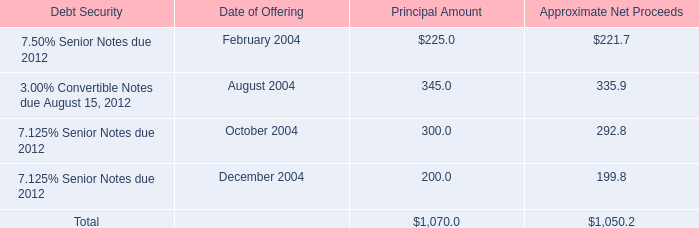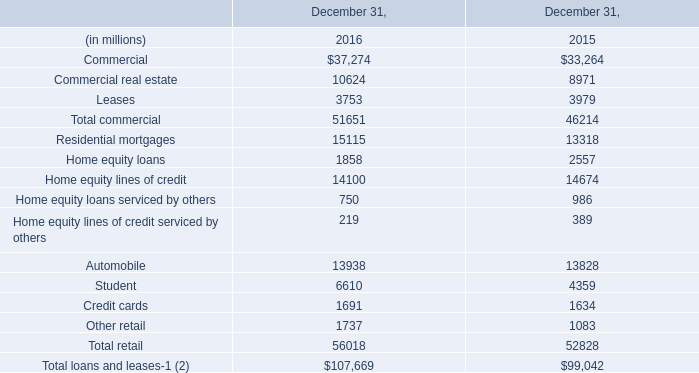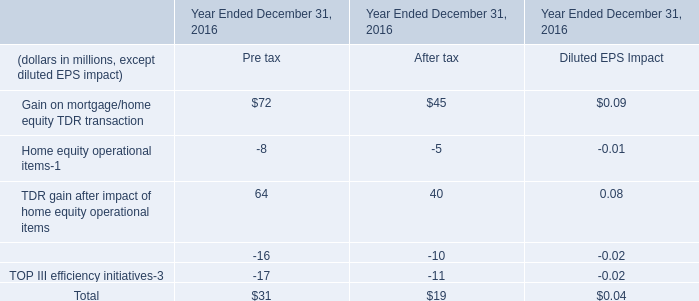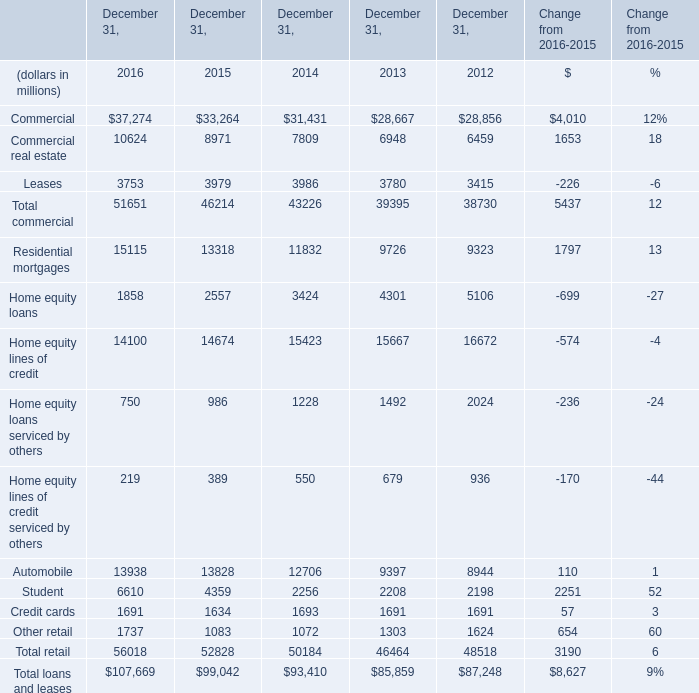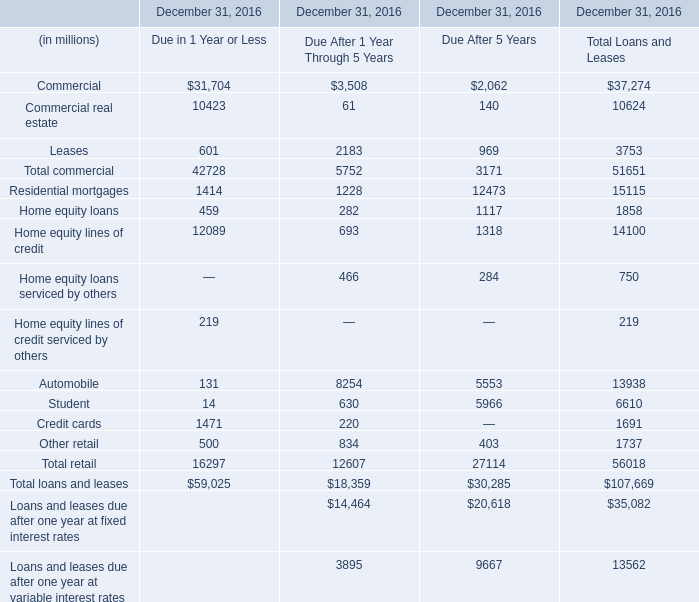What's the average of Home equity loans of December 31, 2016, and Student of December 31, 2016 ? 
Computations: ((1858.0 + 6610.0) / 2)
Answer: 4234.0. 